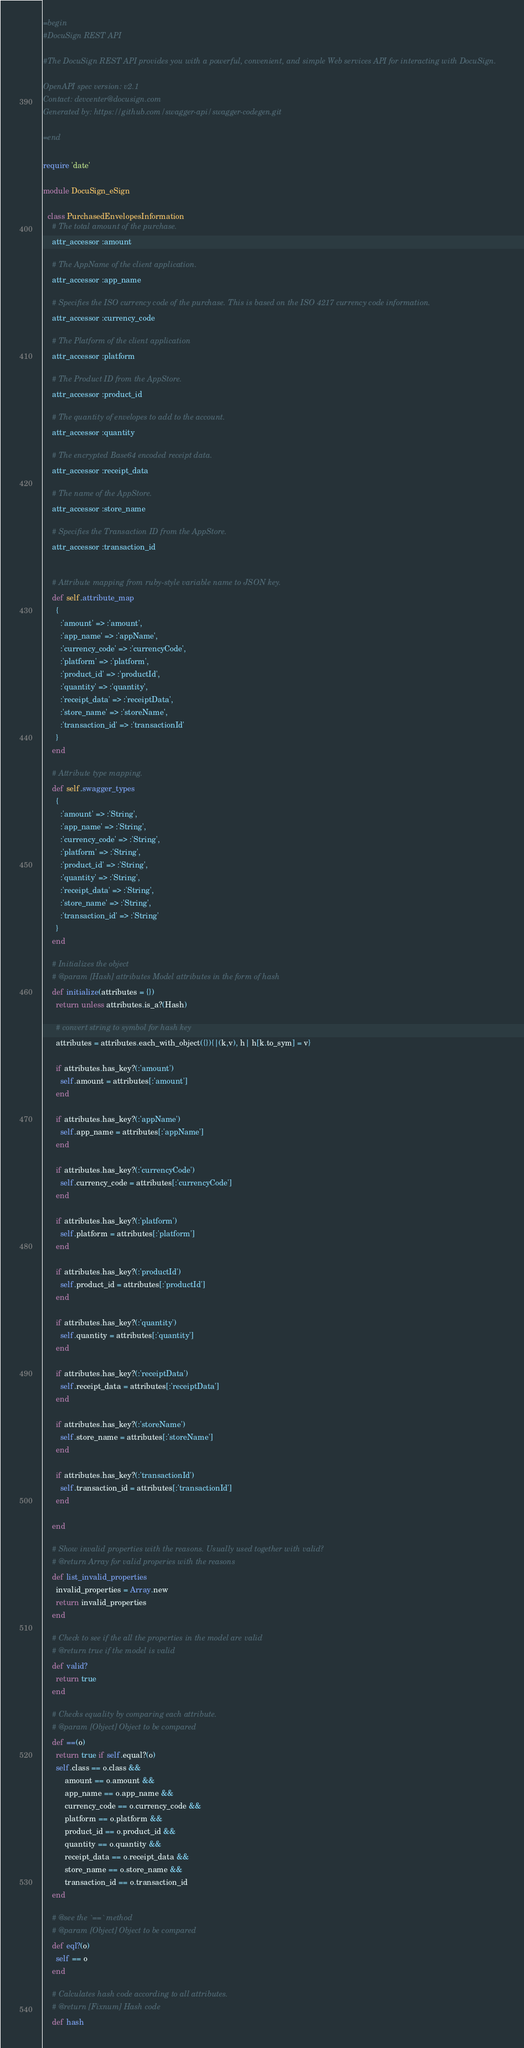<code> <loc_0><loc_0><loc_500><loc_500><_Ruby_>=begin
#DocuSign REST API

#The DocuSign REST API provides you with a powerful, convenient, and simple Web services API for interacting with DocuSign.

OpenAPI spec version: v2.1
Contact: devcenter@docusign.com
Generated by: https://github.com/swagger-api/swagger-codegen.git

=end

require 'date'

module DocuSign_eSign

  class PurchasedEnvelopesInformation
    # The total amount of the purchase.
    attr_accessor :amount

    # The AppName of the client application.
    attr_accessor :app_name

    # Specifies the ISO currency code of the purchase. This is based on the ISO 4217 currency code information.
    attr_accessor :currency_code

    # The Platform of the client application
    attr_accessor :platform

    # The Product ID from the AppStore.
    attr_accessor :product_id

    # The quantity of envelopes to add to the account.
    attr_accessor :quantity

    # The encrypted Base64 encoded receipt data.
    attr_accessor :receipt_data

    # The name of the AppStore.
    attr_accessor :store_name

    # Specifies the Transaction ID from the AppStore.
    attr_accessor :transaction_id


    # Attribute mapping from ruby-style variable name to JSON key.
    def self.attribute_map
      {
        :'amount' => :'amount',
        :'app_name' => :'appName',
        :'currency_code' => :'currencyCode',
        :'platform' => :'platform',
        :'product_id' => :'productId',
        :'quantity' => :'quantity',
        :'receipt_data' => :'receiptData',
        :'store_name' => :'storeName',
        :'transaction_id' => :'transactionId'
      }
    end

    # Attribute type mapping.
    def self.swagger_types
      {
        :'amount' => :'String',
        :'app_name' => :'String',
        :'currency_code' => :'String',
        :'platform' => :'String',
        :'product_id' => :'String',
        :'quantity' => :'String',
        :'receipt_data' => :'String',
        :'store_name' => :'String',
        :'transaction_id' => :'String'
      }
    end

    # Initializes the object
    # @param [Hash] attributes Model attributes in the form of hash
    def initialize(attributes = {})
      return unless attributes.is_a?(Hash)

      # convert string to symbol for hash key
      attributes = attributes.each_with_object({}){|(k,v), h| h[k.to_sym] = v}

      if attributes.has_key?(:'amount')
        self.amount = attributes[:'amount']
      end

      if attributes.has_key?(:'appName')
        self.app_name = attributes[:'appName']
      end

      if attributes.has_key?(:'currencyCode')
        self.currency_code = attributes[:'currencyCode']
      end

      if attributes.has_key?(:'platform')
        self.platform = attributes[:'platform']
      end

      if attributes.has_key?(:'productId')
        self.product_id = attributes[:'productId']
      end

      if attributes.has_key?(:'quantity')
        self.quantity = attributes[:'quantity']
      end

      if attributes.has_key?(:'receiptData')
        self.receipt_data = attributes[:'receiptData']
      end

      if attributes.has_key?(:'storeName')
        self.store_name = attributes[:'storeName']
      end

      if attributes.has_key?(:'transactionId')
        self.transaction_id = attributes[:'transactionId']
      end

    end

    # Show invalid properties with the reasons. Usually used together with valid?
    # @return Array for valid properies with the reasons
    def list_invalid_properties
      invalid_properties = Array.new
      return invalid_properties
    end

    # Check to see if the all the properties in the model are valid
    # @return true if the model is valid
    def valid?
      return true
    end

    # Checks equality by comparing each attribute.
    # @param [Object] Object to be compared
    def ==(o)
      return true if self.equal?(o)
      self.class == o.class &&
          amount == o.amount &&
          app_name == o.app_name &&
          currency_code == o.currency_code &&
          platform == o.platform &&
          product_id == o.product_id &&
          quantity == o.quantity &&
          receipt_data == o.receipt_data &&
          store_name == o.store_name &&
          transaction_id == o.transaction_id
    end

    # @see the `==` method
    # @param [Object] Object to be compared
    def eql?(o)
      self == o
    end

    # Calculates hash code according to all attributes.
    # @return [Fixnum] Hash code
    def hash</code> 